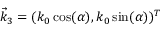Convert formula to latex. <formula><loc_0><loc_0><loc_500><loc_500>\vec { k } _ { 3 } = ( k _ { 0 } \cos ( \alpha ) , k _ { 0 } \sin ( \alpha ) ) ^ { T }</formula> 